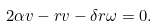Convert formula to latex. <formula><loc_0><loc_0><loc_500><loc_500>2 \alpha v - r v - \delta r \omega = 0 .</formula> 